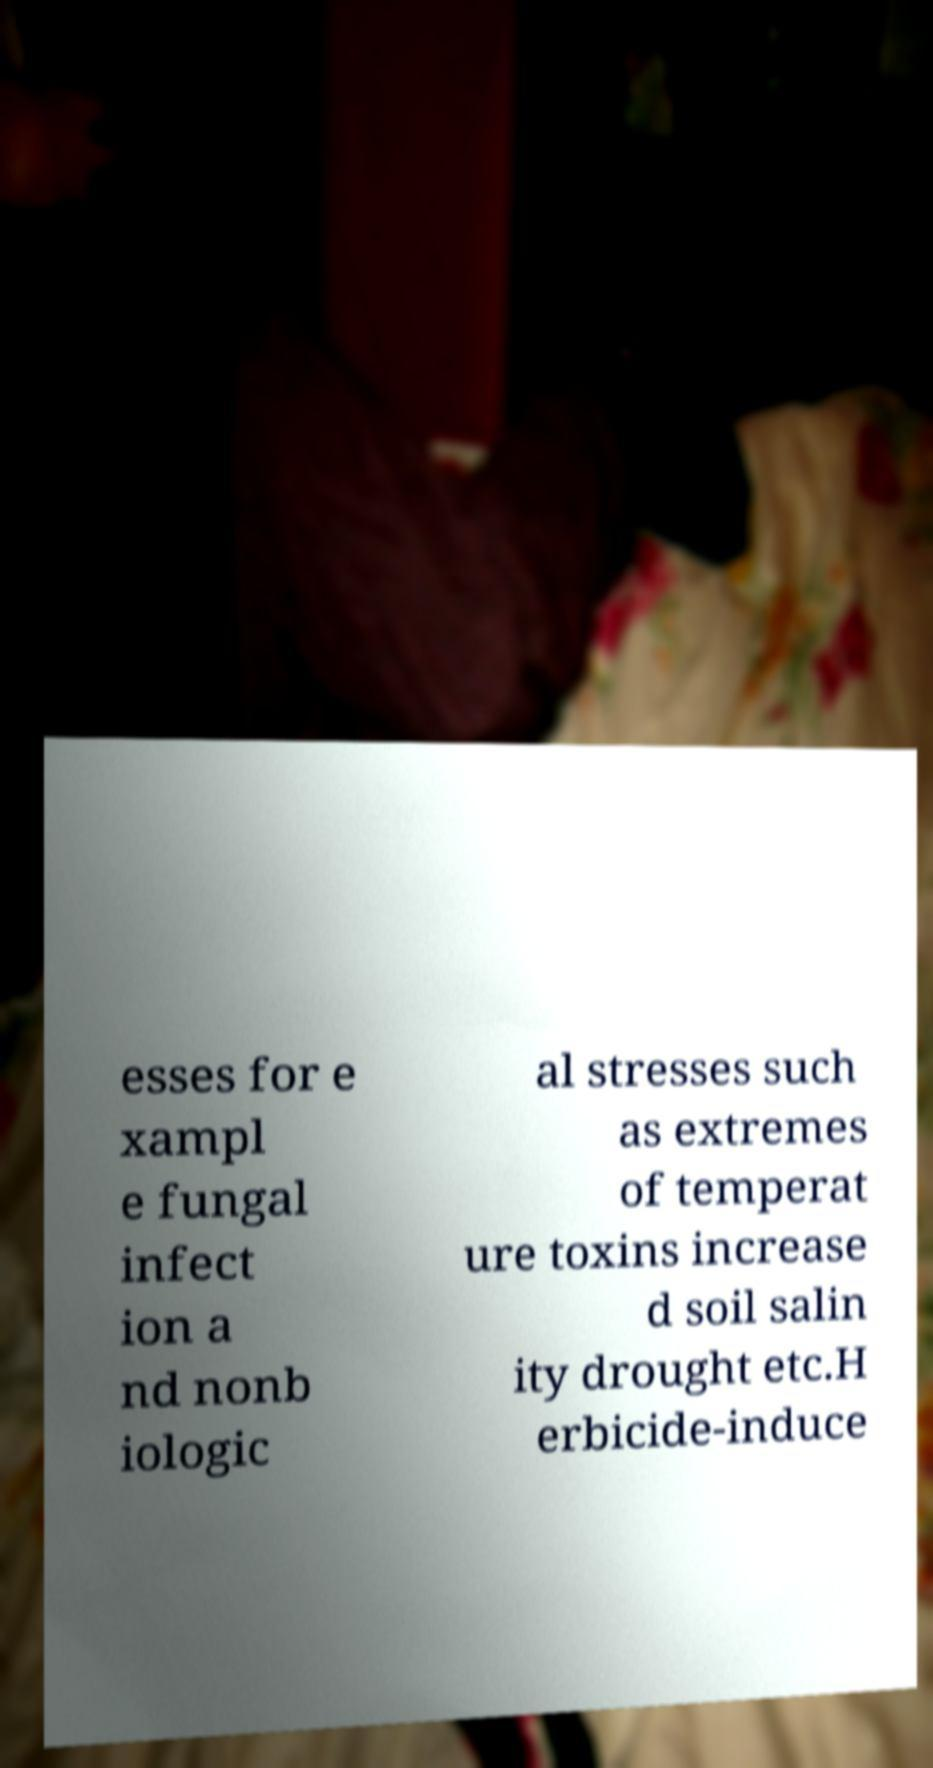For documentation purposes, I need the text within this image transcribed. Could you provide that? esses for e xampl e fungal infect ion a nd nonb iologic al stresses such as extremes of temperat ure toxins increase d soil salin ity drought etc.H erbicide-induce 